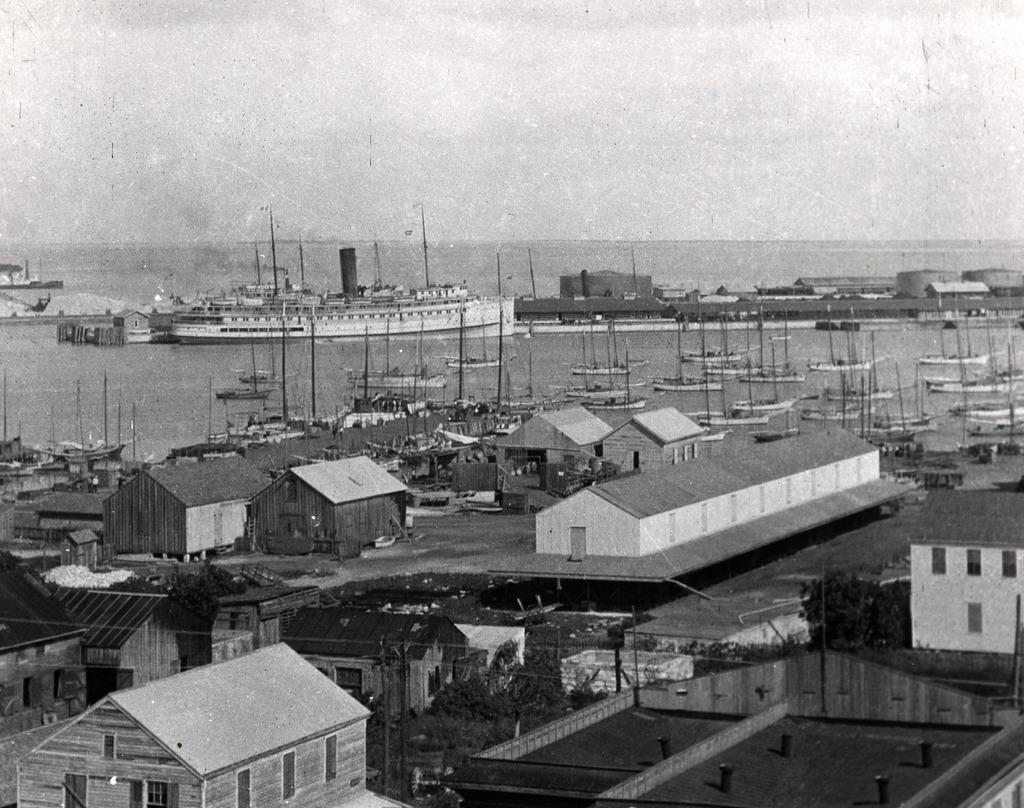Could you give a brief overview of what you see in this image? This is a black and white image and here we can see sheds, trees, poles and there are ships and boats on the water. 